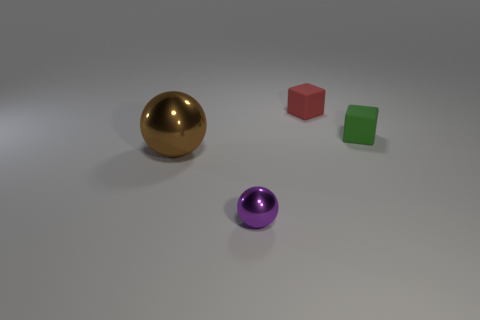Add 1 big gray rubber things. How many objects exist? 5 Subtract 0 cyan cubes. How many objects are left? 4 Subtract all small gray rubber objects. Subtract all tiny shiny objects. How many objects are left? 3 Add 3 small green things. How many small green things are left? 4 Add 2 brown matte balls. How many brown matte balls exist? 2 